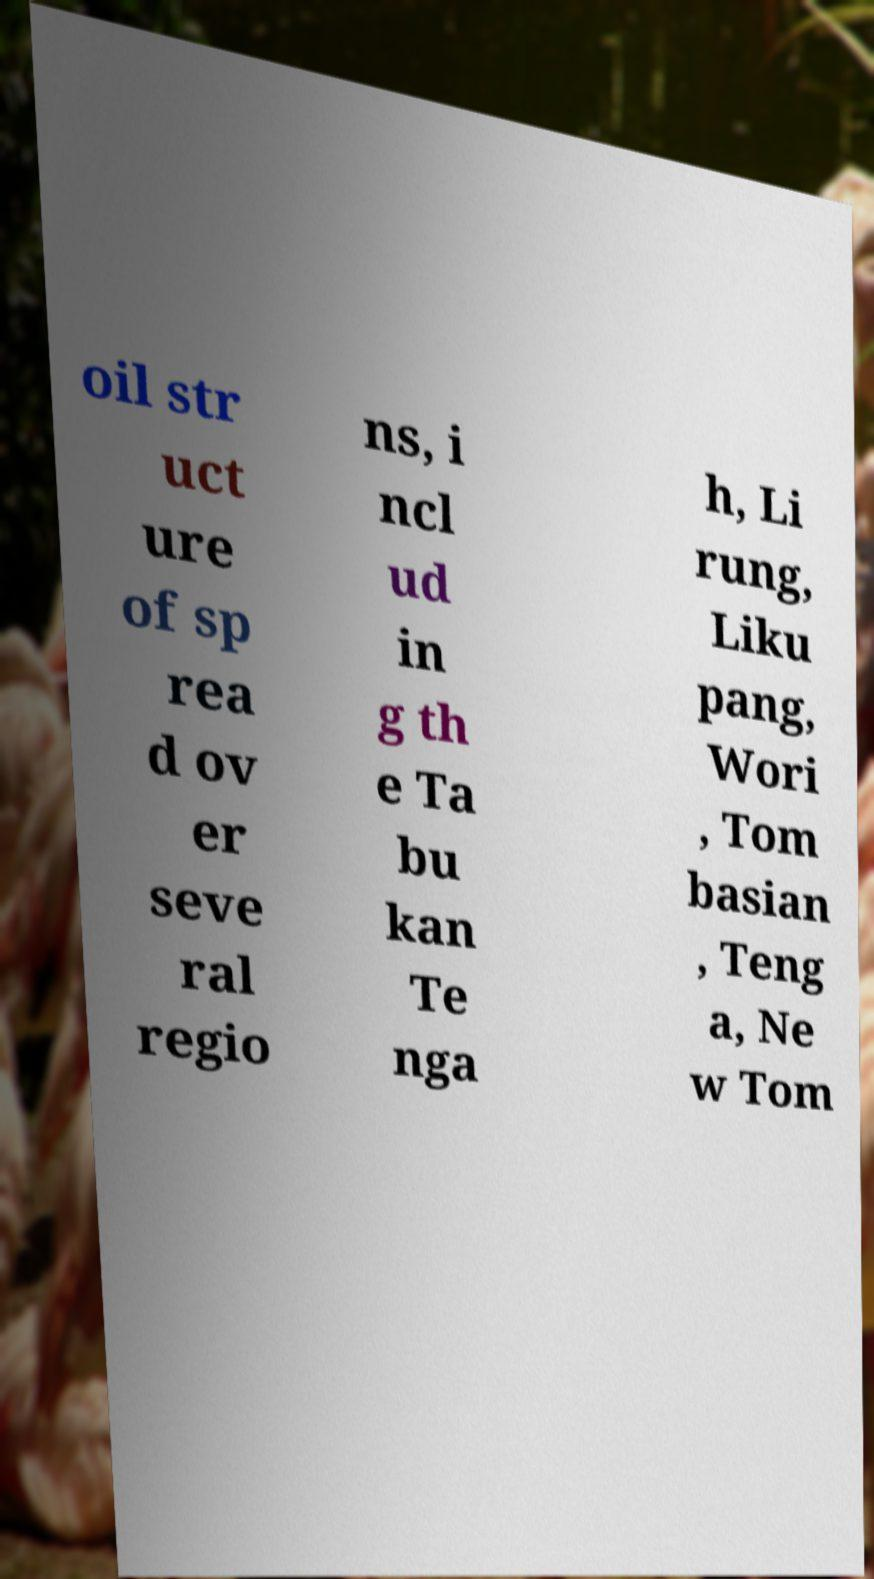What messages or text are displayed in this image? I need them in a readable, typed format. oil str uct ure of sp rea d ov er seve ral regio ns, i ncl ud in g th e Ta bu kan Te nga h, Li rung, Liku pang, Wori , Tom basian , Teng a, Ne w Tom 